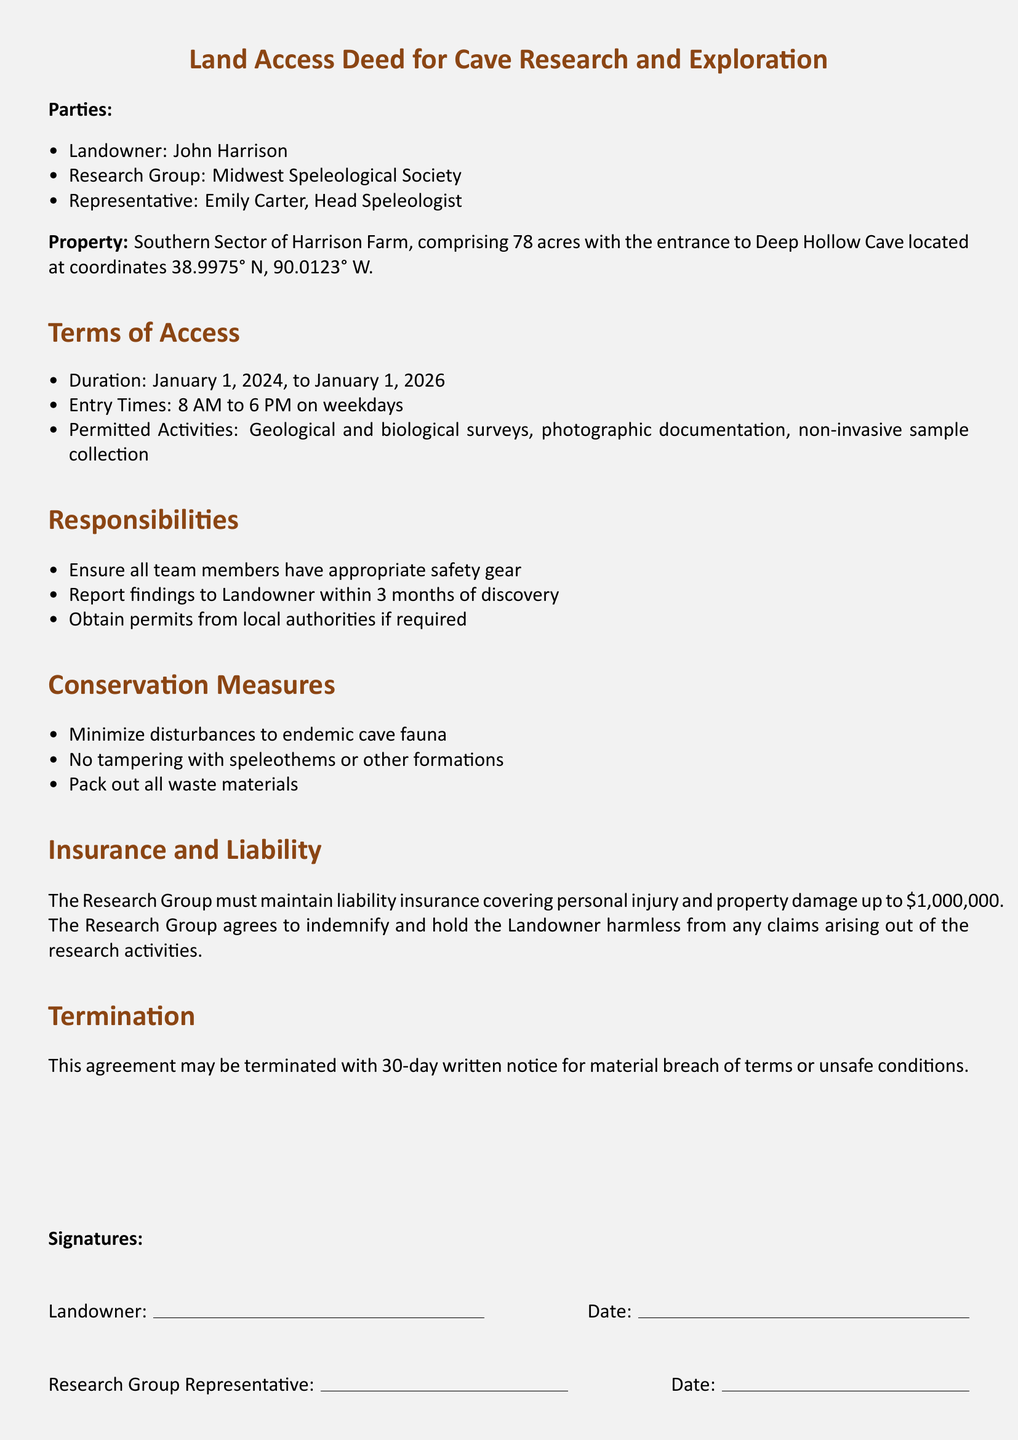What is the name of the landowner? The name of the landowner is listed at the beginning of the document as John Harrison.
Answer: John Harrison Who represents the Research Group? The representative of the Research Group is specified as Emily Carter, who is the Head Speleologist.
Answer: Emily Carter What is the duration of access granted by the deed? The duration mentioned in the document is from January 1, 2024, to January 1, 2026.
Answer: January 1, 2024, to January 1, 2026 What time can the Research Group enter the property? The entry times specified in the deed are from 8 AM to 6 PM on weekdays.
Answer: 8 AM to 6 PM What must the Research Group do if they discover something? The document states that the team must report findings to the Landowner within 3 months of discovery.
Answer: Within 3 months What types of surveys are permitted according to the Deed? The permitted activities include geological and biological surveys as mentioned in the terms of access.
Answer: Geological and biological surveys What is one of the conservation measures listed in the document? Among the conservation measures, it is stated that there should be no tampering with speleothems or other formations.
Answer: No tampering with speleothems What is the maximum liability insurance amount required? The document mentions a liability insurance coverage requirement of up to one million dollars for personal injury and property damage.
Answer: One million dollars What is the notice period for termination of the agreement? The deed specifies that a 30-day written notice must be given for termination due to material breach of terms or unsafe conditions.
Answer: 30-day written notice 